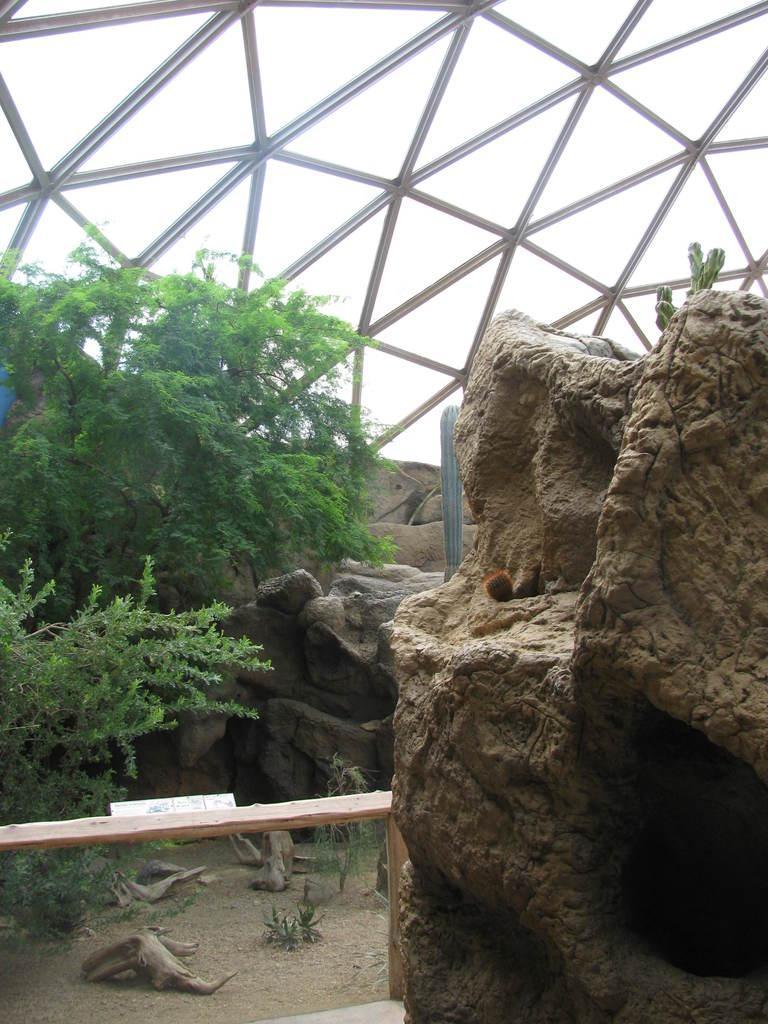How would you summarize this image in a sentence or two? In this picture, it seems like rocks on the right side and a bamboo on the left side. There are trees, trunks and a roof in the background area. 